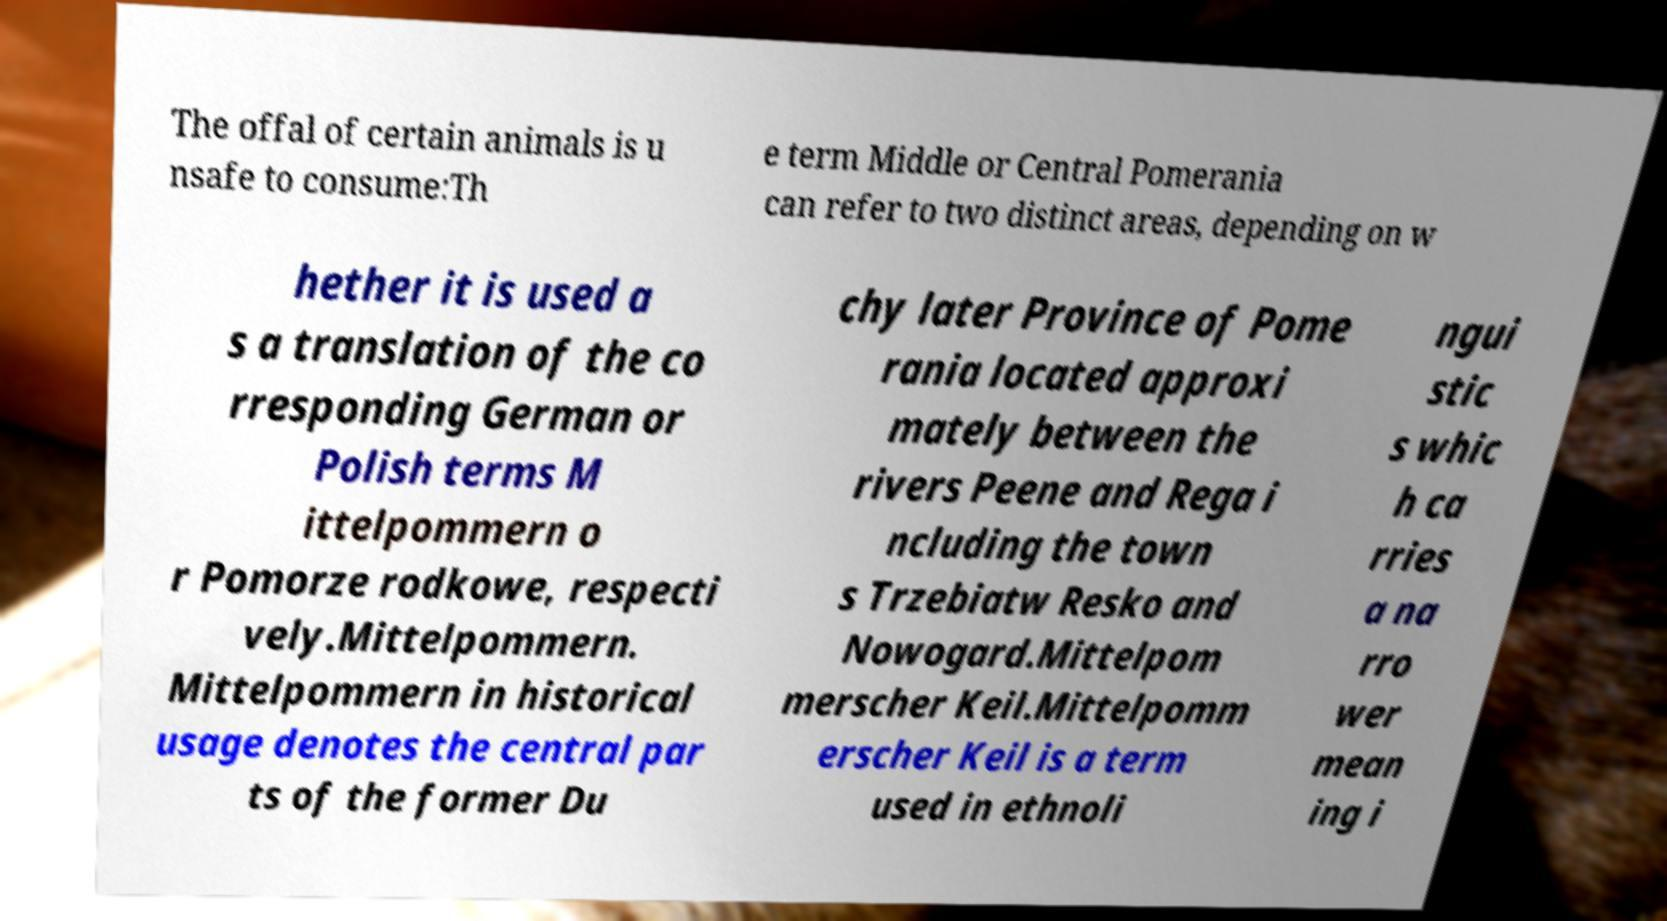Could you assist in decoding the text presented in this image and type it out clearly? The offal of certain animals is u nsafe to consume:Th e term Middle or Central Pomerania can refer to two distinct areas, depending on w hether it is used a s a translation of the co rresponding German or Polish terms M ittelpommern o r Pomorze rodkowe, respecti vely.Mittelpommern. Mittelpommern in historical usage denotes the central par ts of the former Du chy later Province of Pome rania located approxi mately between the rivers Peene and Rega i ncluding the town s Trzebiatw Resko and Nowogard.Mittelpom merscher Keil.Mittelpomm erscher Keil is a term used in ethnoli ngui stic s whic h ca rries a na rro wer mean ing i 